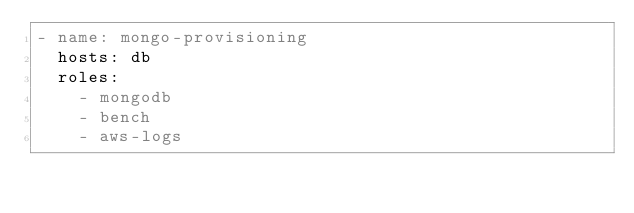Convert code to text. <code><loc_0><loc_0><loc_500><loc_500><_YAML_>- name: mongo-provisioning
  hosts: db
  roles:
    - mongodb
    - bench
    - aws-logs
</code> 